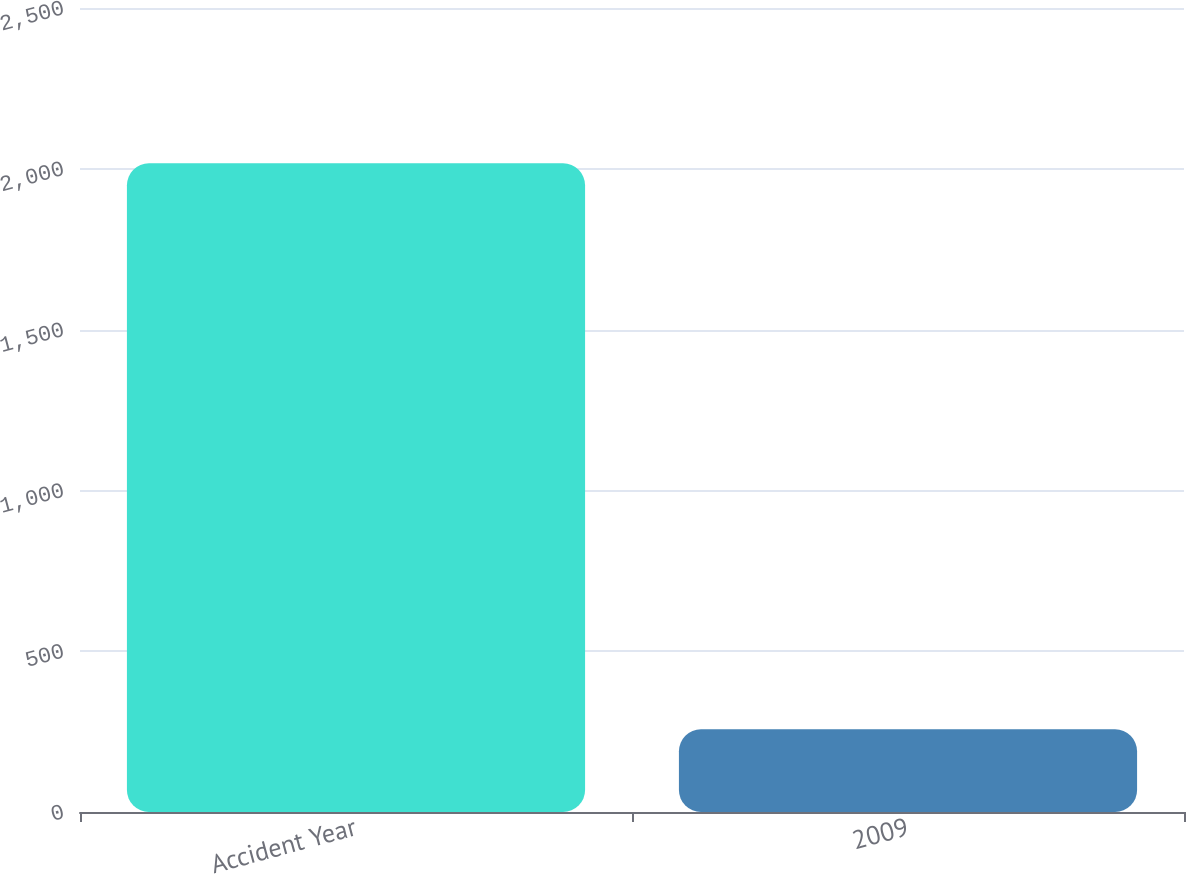Convert chart to OTSL. <chart><loc_0><loc_0><loc_500><loc_500><bar_chart><fcel>Accident Year<fcel>2009<nl><fcel>2017<fcel>257<nl></chart> 